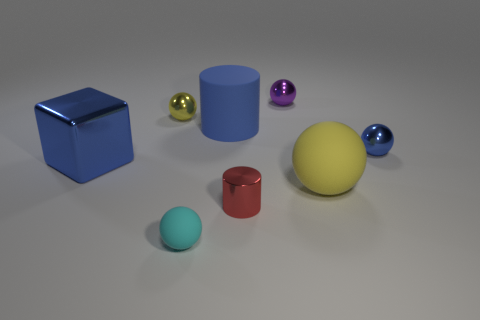How many yellow balls must be subtracted to get 1 yellow balls? 1 Subtract all spheres. How many objects are left? 3 Subtract all small purple metallic balls. How many balls are left? 4 Subtract 2 spheres. How many spheres are left? 3 Subtract all purple cylinders. Subtract all red cubes. How many cylinders are left? 2 Subtract all green cylinders. How many brown blocks are left? 0 Subtract all big metal cubes. Subtract all large blue metallic blocks. How many objects are left? 6 Add 3 small red metallic cylinders. How many small red metallic cylinders are left? 4 Add 7 big metal objects. How many big metal objects exist? 8 Add 1 large blocks. How many objects exist? 9 